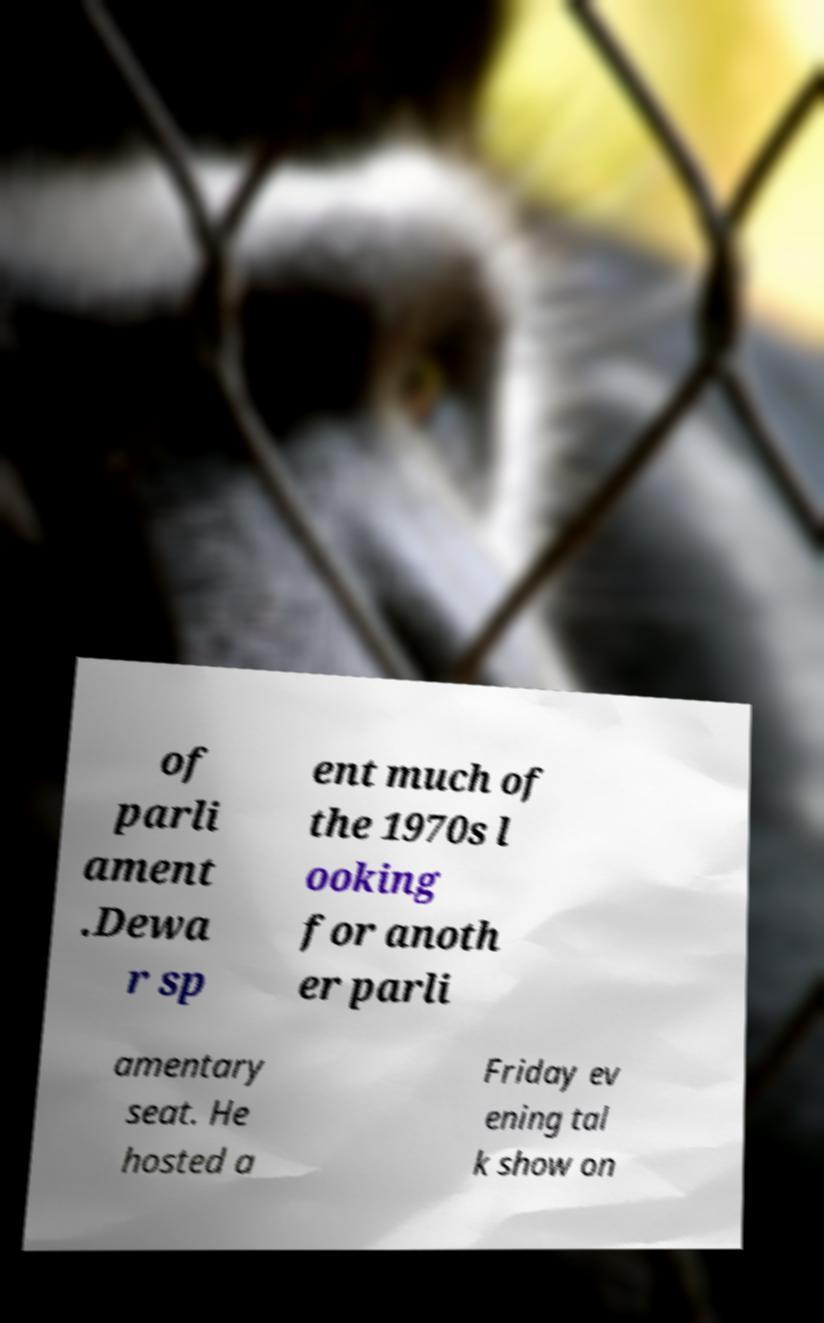There's text embedded in this image that I need extracted. Can you transcribe it verbatim? of parli ament .Dewa r sp ent much of the 1970s l ooking for anoth er parli amentary seat. He hosted a Friday ev ening tal k show on 